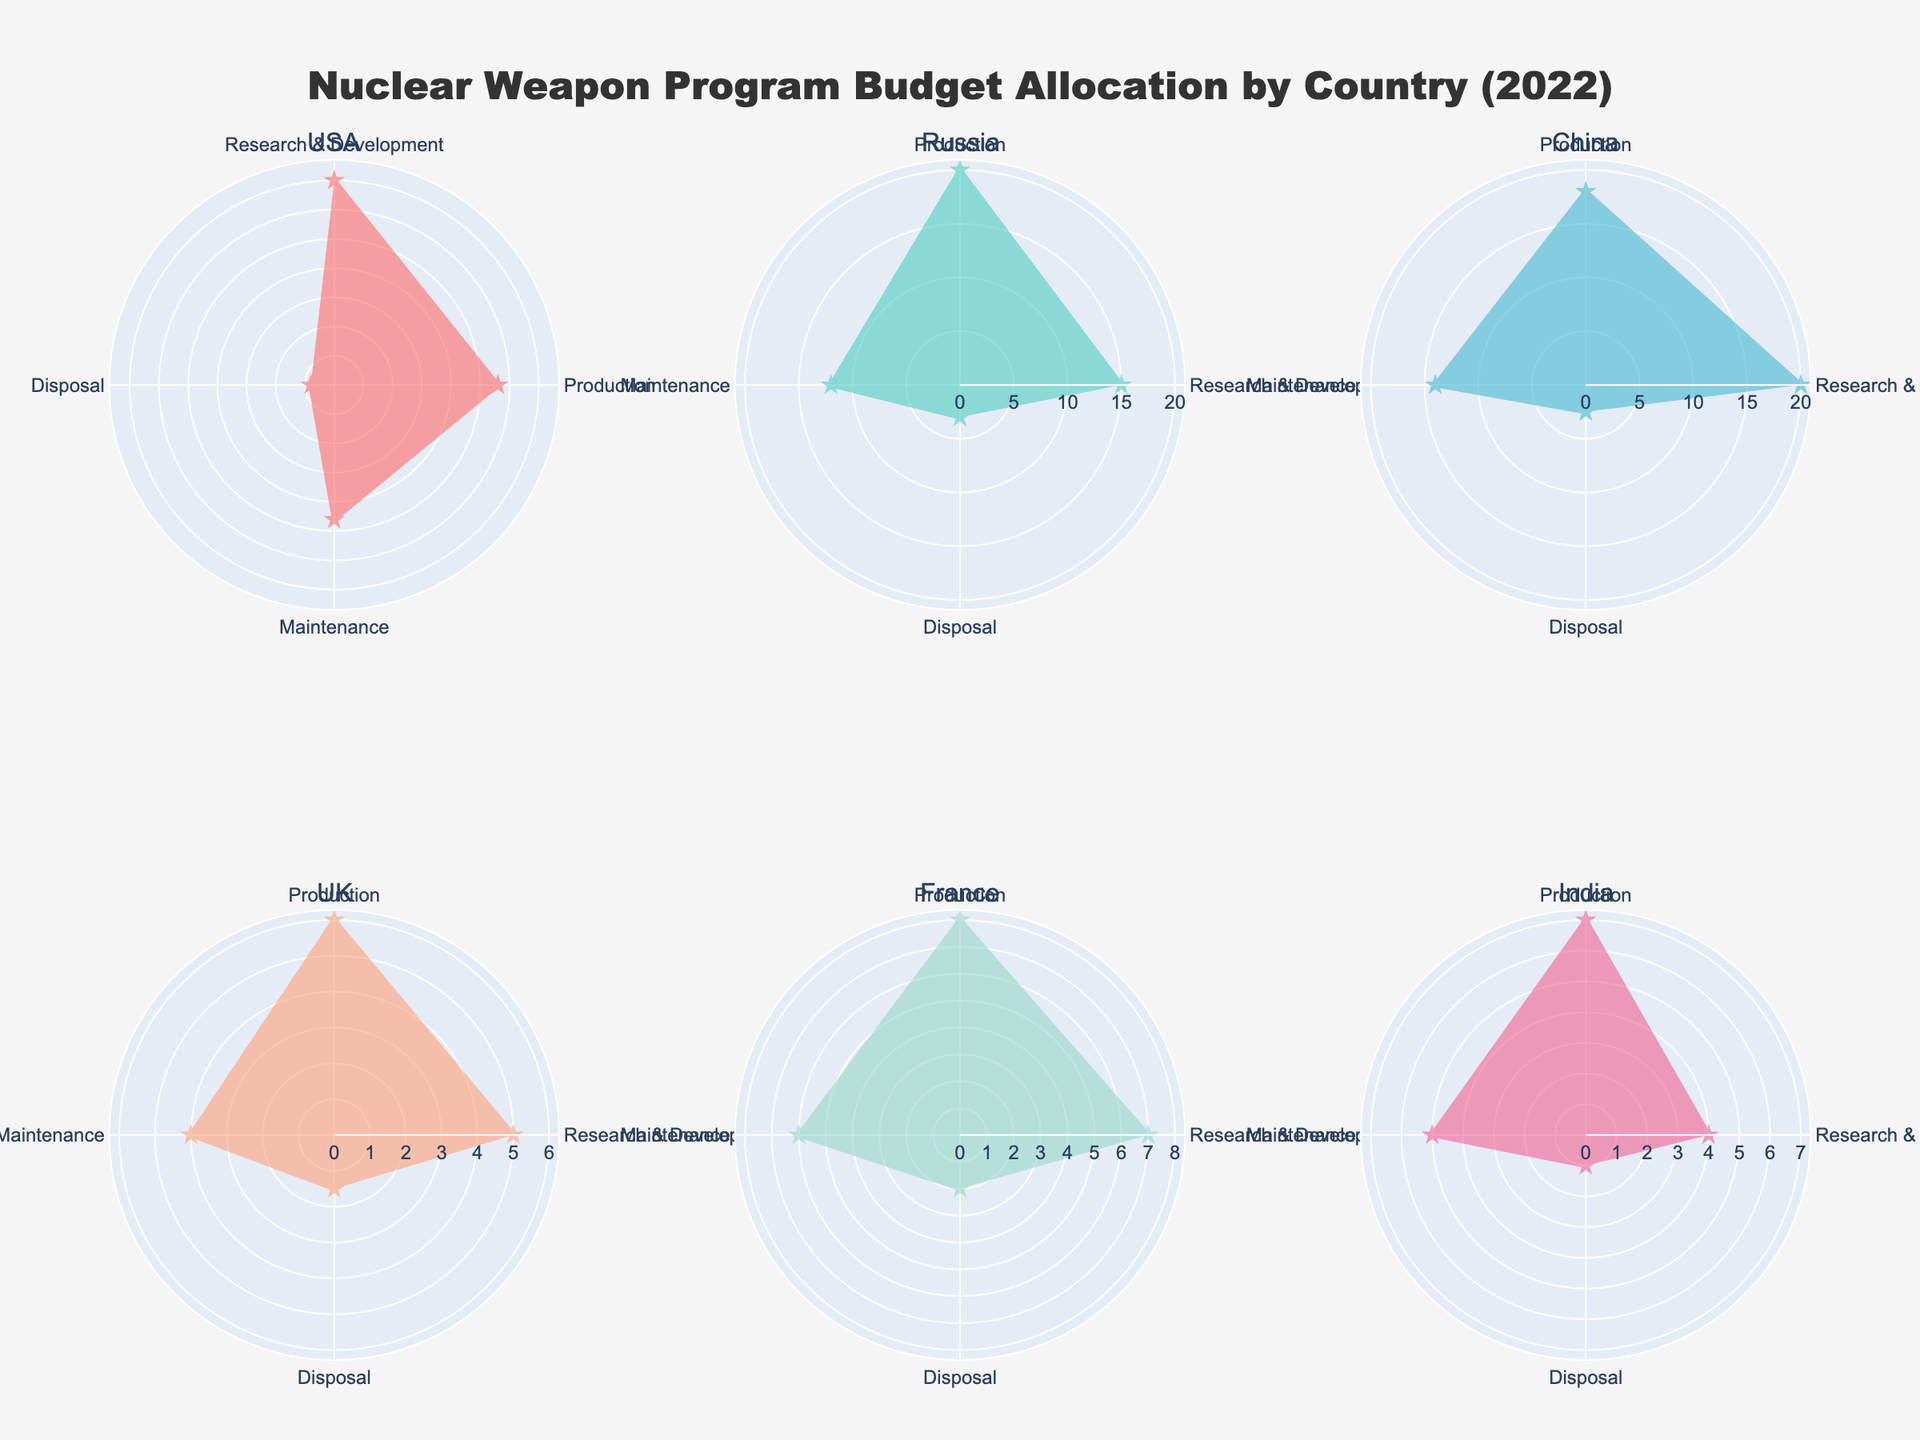What is the title of the figure? The title of the figure is located at the top and reads "Nuclear Weapon Program Budget Allocation by Country (2022)".
Answer: Nuclear Weapon Program Budget Allocation by Country (2022) Which country allocated the most budget to Research & Development? By comparing the Research & Development spending in the radar chart, the USA has the highest amount allocated to this category.
Answer: USA How much did China allocate to Disposal? From the radar chart, we see China's Disposal funding is marked at $2.5 billion USD.
Answer: $2.5 billion Compare the Maintenance budget between France and the UK. France's budget for Maintenance is $6 billion, while the UK's budget is $4 billion. Therefore, France allocated $2 billion more than the UK.
Answer: France allocated $2 billion more What is the average budget allocation for Production across all listed countries? Summing the Production budgets for all countries: USA ($28B) + Russia ($20B) + China ($18B) + UK ($6B) + France ($8B) + India ($7B). The total is $87 billion. There are 6 countries, so the average is $87B / 6 = $14.5 billion.
Answer: $14.5 billion Which category has the smallest budget allocation from India, and how does it compare to the same category in the USA? India's smallest budget allocation is for Disposal, at $1 billion. The USA's Disposal budget is $4 billion. Therefore, India's allocation is $3 billion less than the USA's.
Answer: Disposal; it is $3 billion less than the USA's Overall, which country has the lowest total budget allocation across all categories? Summing the budgets for each country: USA ($35B + $28B + $23B + $4B = $90B), Russia ($15B + $20B + $12B + $3B = $50B), China ($20B + $18B + $14B + $2.5B = $54.5B), UK ($5B + $6B + $4B + $1.5B = $16.5B), France ($7B + $8B + $6B + $2B = $23B), India ($4B + $7B + $5B + $1B = $17B). The UK has the lowest total budget allocation.
Answer: UK What is the difference in the Production budget between the countries with the highest and lowest allocations in this category? USA has the highest Production budget ($28B) and the UK has the lowest ($6B). The difference is $28B - $6B = $22 billion.
Answer: $22 billion How many categories are being tracked in this figure? The radar chart tracks 4 categories: Research & Development, Production, Maintenance, and Disposal.
Answer: 4 categories 